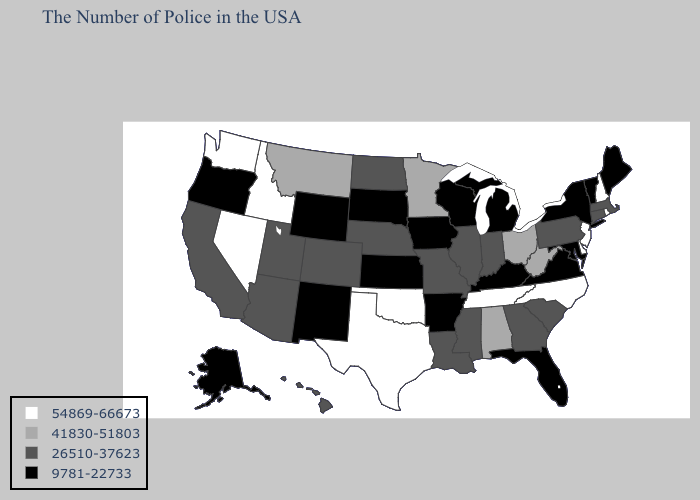Which states hav the highest value in the West?
Quick response, please. Idaho, Nevada, Washington. Does New Hampshire have the lowest value in the Northeast?
Keep it brief. No. Which states have the lowest value in the South?
Write a very short answer. Maryland, Virginia, Florida, Kentucky, Arkansas. Name the states that have a value in the range 9781-22733?
Concise answer only. Maine, Vermont, New York, Maryland, Virginia, Florida, Michigan, Kentucky, Wisconsin, Arkansas, Iowa, Kansas, South Dakota, Wyoming, New Mexico, Oregon, Alaska. Name the states that have a value in the range 9781-22733?
Write a very short answer. Maine, Vermont, New York, Maryland, Virginia, Florida, Michigan, Kentucky, Wisconsin, Arkansas, Iowa, Kansas, South Dakota, Wyoming, New Mexico, Oregon, Alaska. What is the highest value in states that border Georgia?
Quick response, please. 54869-66673. Name the states that have a value in the range 9781-22733?
Write a very short answer. Maine, Vermont, New York, Maryland, Virginia, Florida, Michigan, Kentucky, Wisconsin, Arkansas, Iowa, Kansas, South Dakota, Wyoming, New Mexico, Oregon, Alaska. What is the value of Minnesota?
Short answer required. 41830-51803. Which states hav the highest value in the MidWest?
Concise answer only. Ohio, Minnesota. What is the value of South Dakota?
Concise answer only. 9781-22733. What is the value of Delaware?
Give a very brief answer. 54869-66673. Name the states that have a value in the range 9781-22733?
Answer briefly. Maine, Vermont, New York, Maryland, Virginia, Florida, Michigan, Kentucky, Wisconsin, Arkansas, Iowa, Kansas, South Dakota, Wyoming, New Mexico, Oregon, Alaska. What is the value of Wyoming?
Give a very brief answer. 9781-22733. Name the states that have a value in the range 54869-66673?
Give a very brief answer. Rhode Island, New Hampshire, New Jersey, Delaware, North Carolina, Tennessee, Oklahoma, Texas, Idaho, Nevada, Washington. Which states have the highest value in the USA?
Be succinct. Rhode Island, New Hampshire, New Jersey, Delaware, North Carolina, Tennessee, Oklahoma, Texas, Idaho, Nevada, Washington. 